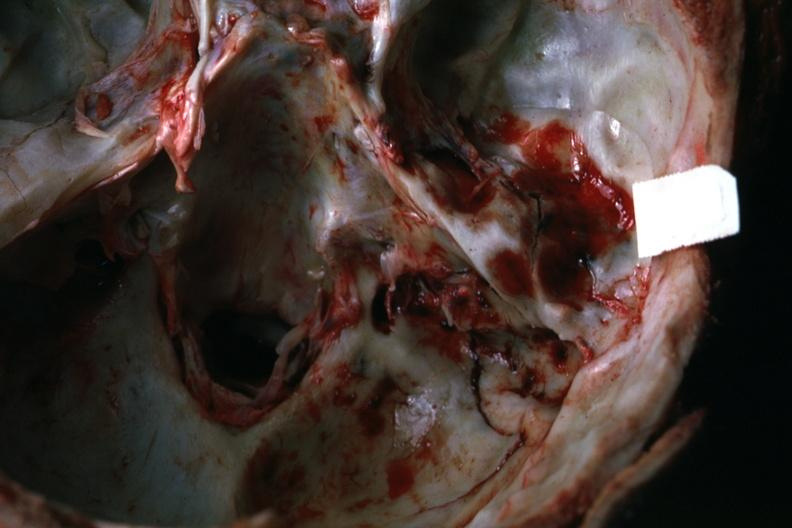what is present?
Answer the question using a single word or phrase. Basilar skull fracture 